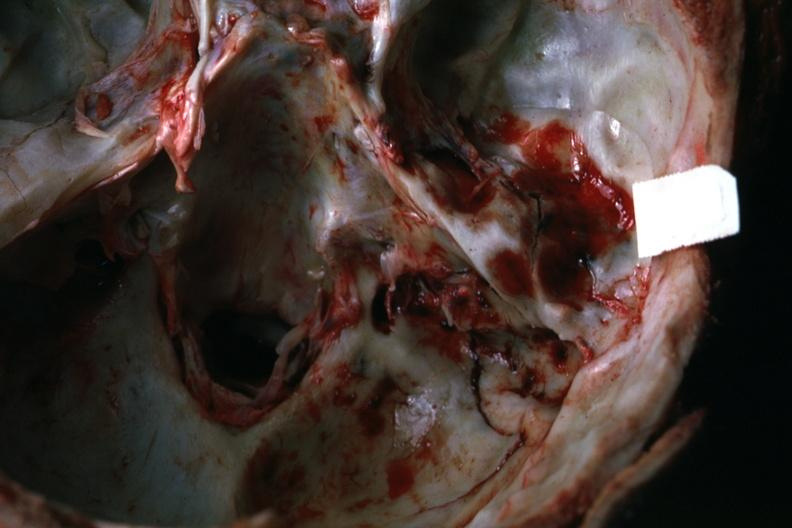what is present?
Answer the question using a single word or phrase. Basilar skull fracture 